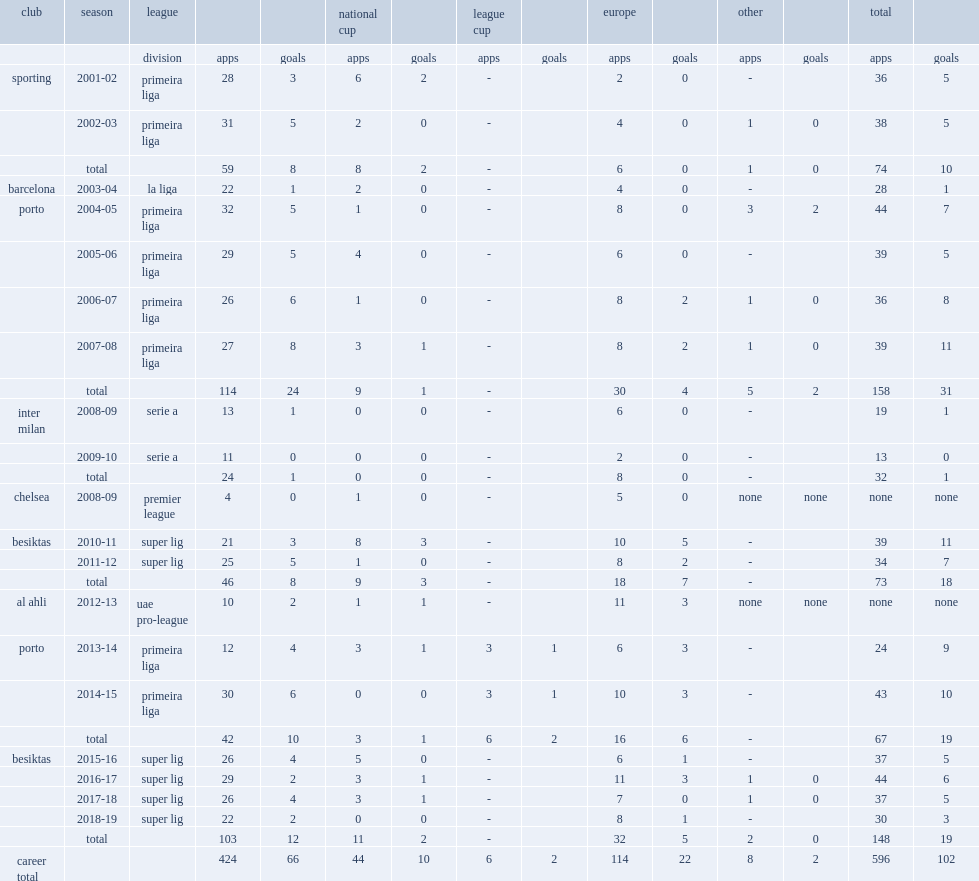During 2001-02 season, how many matches did ricardo quaresma play in primeira liga at sporting? 28.0. During 2001-02 season, how many goals did ricardo quaresma played in 28 primeira liga matches and score at sporting? 3.0. Could you parse the entire table as a dict? {'header': ['club', 'season', 'league', '', '', 'national cup', '', 'league cup', '', 'europe', '', 'other', '', 'total', ''], 'rows': [['', '', 'division', 'apps', 'goals', 'apps', 'goals', 'apps', 'goals', 'apps', 'goals', 'apps', 'goals', 'apps', 'goals'], ['sporting', '2001-02', 'primeira liga', '28', '3', '6', '2', '-', '', '2', '0', '-', '', '36', '5'], ['', '2002-03', 'primeira liga', '31', '5', '2', '0', '-', '', '4', '0', '1', '0', '38', '5'], ['', 'total', '', '59', '8', '8', '2', '-', '', '6', '0', '1', '0', '74', '10'], ['barcelona', '2003-04', 'la liga', '22', '1', '2', '0', '-', '', '4', '0', '-', '', '28', '1'], ['porto', '2004-05', 'primeira liga', '32', '5', '1', '0', '-', '', '8', '0', '3', '2', '44', '7'], ['', '2005-06', 'primeira liga', '29', '5', '4', '0', '-', '', '6', '0', '-', '', '39', '5'], ['', '2006-07', 'primeira liga', '26', '6', '1', '0', '-', '', '8', '2', '1', '0', '36', '8'], ['', '2007-08', 'primeira liga', '27', '8', '3', '1', '-', '', '8', '2', '1', '0', '39', '11'], ['', 'total', '', '114', '24', '9', '1', '-', '', '30', '4', '5', '2', '158', '31'], ['inter milan', '2008-09', 'serie a', '13', '1', '0', '0', '-', '', '6', '0', '-', '', '19', '1'], ['', '2009-10', 'serie a', '11', '0', '0', '0', '-', '', '2', '0', '-', '', '13', '0'], ['', 'total', '', '24', '1', '0', '0', '-', '', '8', '0', '-', '', '32', '1'], ['chelsea', '2008-09', 'premier league', '4', '0', '1', '0', '-', '', '5', '0', 'none', 'none', 'none', 'none'], ['besiktas', '2010-11', 'super lig', '21', '3', '8', '3', '-', '', '10', '5', '-', '', '39', '11'], ['', '2011-12', 'super lig', '25', '5', '1', '0', '-', '', '8', '2', '-', '', '34', '7'], ['', 'total', '', '46', '8', '9', '3', '-', '', '18', '7', '-', '', '73', '18'], ['al ahli', '2012-13', 'uae pro-league', '10', '2', '1', '1', '-', '', '11', '3', 'none', 'none', 'none', 'none'], ['porto', '2013-14', 'primeira liga', '12', '4', '3', '1', '3', '1', '6', '3', '-', '', '24', '9'], ['', '2014-15', 'primeira liga', '30', '6', '0', '0', '3', '1', '10', '3', '-', '', '43', '10'], ['', 'total', '', '42', '10', '3', '1', '6', '2', '16', '6', '-', '', '67', '19'], ['besiktas', '2015-16', 'super lig', '26', '4', '5', '0', '-', '', '6', '1', '-', '', '37', '5'], ['', '2016-17', 'super lig', '29', '2', '3', '1', '-', '', '11', '3', '1', '0', '44', '6'], ['', '2017-18', 'super lig', '26', '4', '3', '1', '-', '', '7', '0', '1', '0', '37', '5'], ['', '2018-19', 'super lig', '22', '2', '0', '0', '-', '', '8', '1', '-', '', '30', '3'], ['', 'total', '', '103', '12', '11', '2', '-', '', '32', '5', '2', '0', '148', '19'], ['career total', '', '', '424', '66', '44', '10', '6', '2', '114', '22', '8', '2', '596', '102']]} 